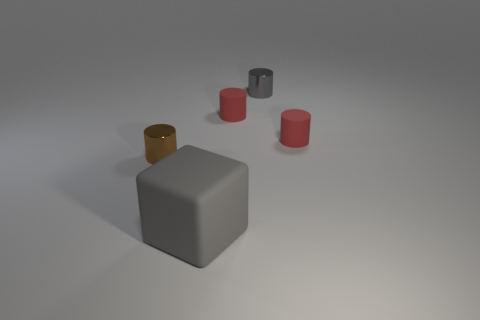Do the brown shiny cylinder and the gray matte object have the same size? No, the brown shiny cylinder and the gray matte object do not have the same size. The brown cylinder is taller and narrower compared to the shorter, wider gray object. This difference in dimension gives each object a distinct appearance despite their basic cylindrical shapes. 